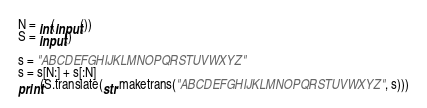<code> <loc_0><loc_0><loc_500><loc_500><_Python_>
N = int(input())
S = input()

s = "ABCDEFGHIJKLMNOPQRSTUVWXYZ"
s = s[N:] + s[:N]
print(S.translate(str.maketrans("ABCDEFGHIJKLMNOPQRSTUVWXYZ", s)))
</code> 